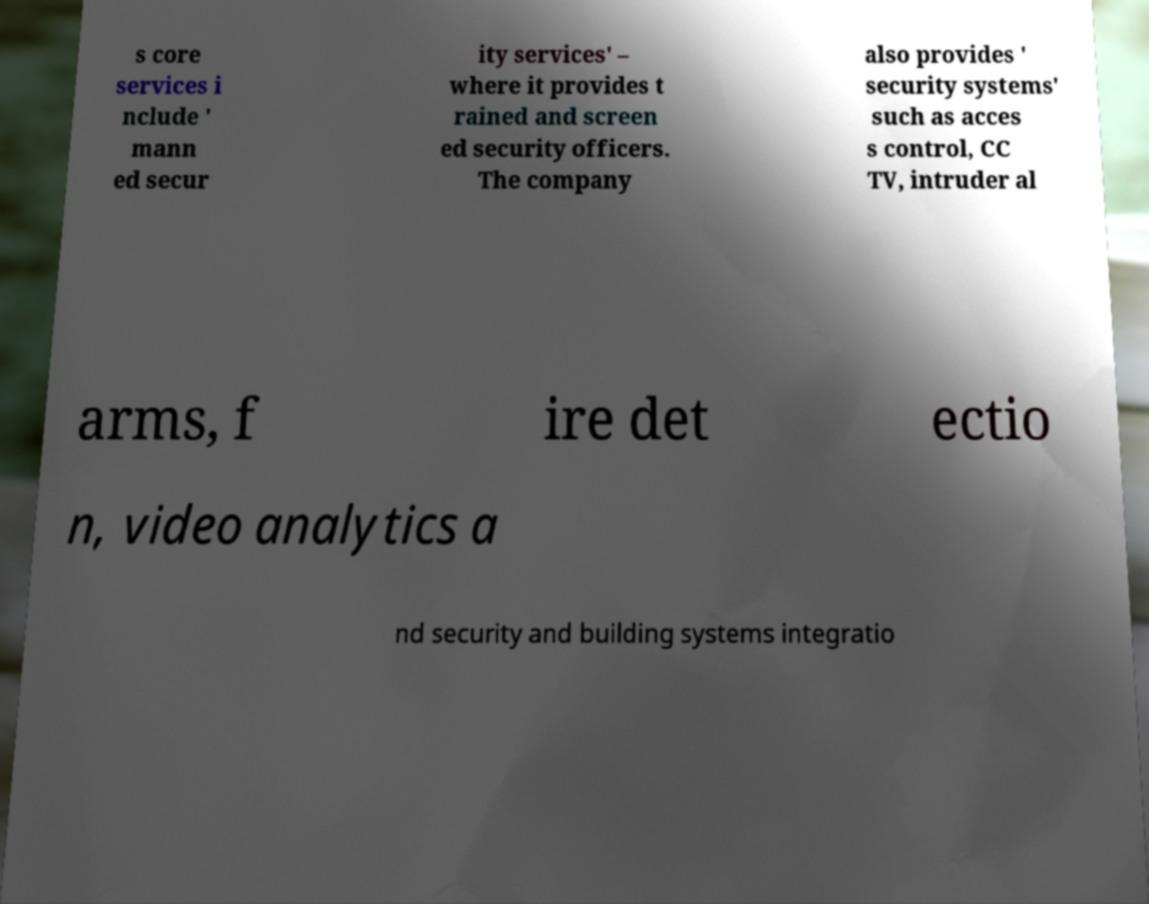I need the written content from this picture converted into text. Can you do that? s core services i nclude ' mann ed secur ity services' – where it provides t rained and screen ed security officers. The company also provides ' security systems' such as acces s control, CC TV, intruder al arms, f ire det ectio n, video analytics a nd security and building systems integratio 